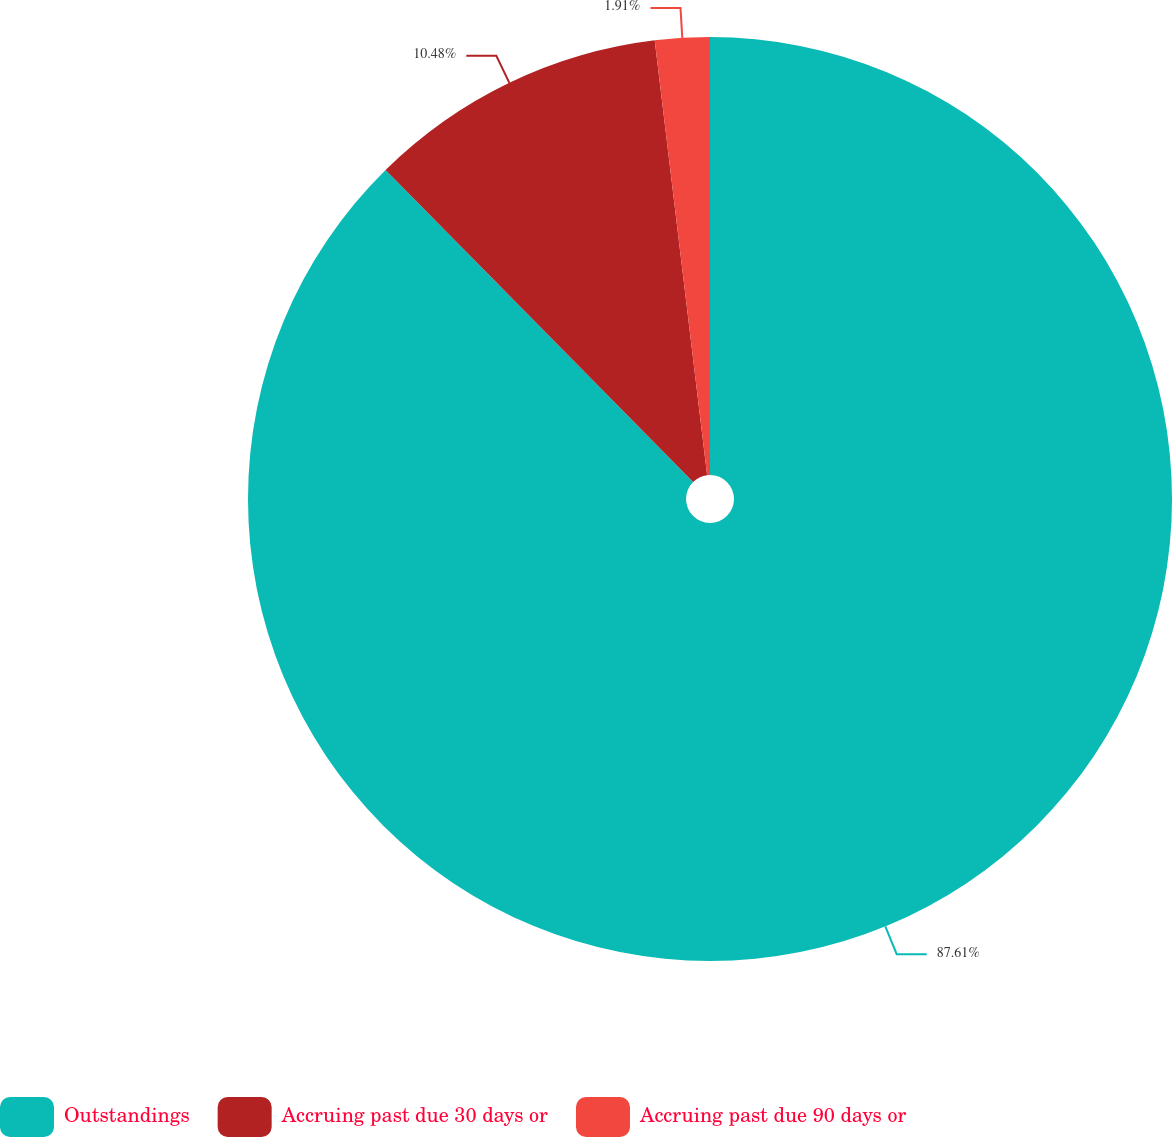Convert chart to OTSL. <chart><loc_0><loc_0><loc_500><loc_500><pie_chart><fcel>Outstandings<fcel>Accruing past due 30 days or<fcel>Accruing past due 90 days or<nl><fcel>87.61%<fcel>10.48%<fcel>1.91%<nl></chart> 